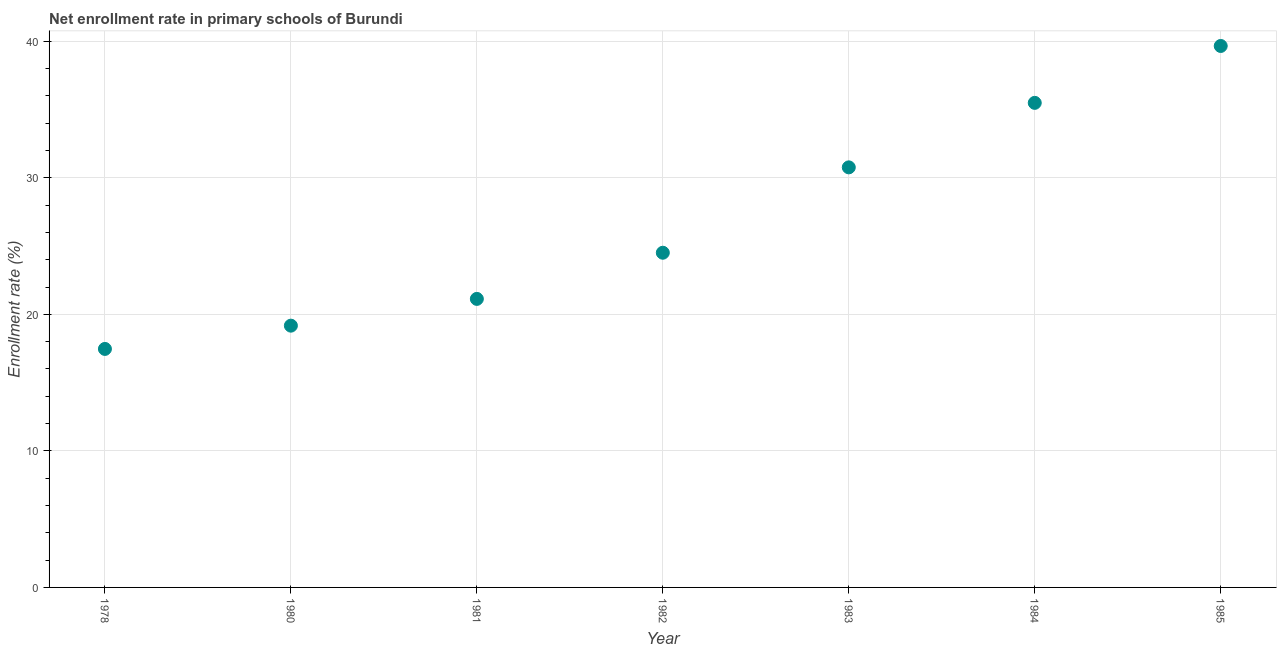What is the net enrollment rate in primary schools in 1978?
Your answer should be very brief. 17.47. Across all years, what is the maximum net enrollment rate in primary schools?
Offer a terse response. 39.65. Across all years, what is the minimum net enrollment rate in primary schools?
Offer a very short reply. 17.47. In which year was the net enrollment rate in primary schools maximum?
Offer a terse response. 1985. In which year was the net enrollment rate in primary schools minimum?
Offer a terse response. 1978. What is the sum of the net enrollment rate in primary schools?
Provide a short and direct response. 188.18. What is the difference between the net enrollment rate in primary schools in 1982 and 1983?
Your answer should be very brief. -6.25. What is the average net enrollment rate in primary schools per year?
Give a very brief answer. 26.88. What is the median net enrollment rate in primary schools?
Make the answer very short. 24.51. What is the ratio of the net enrollment rate in primary schools in 1983 to that in 1984?
Offer a very short reply. 0.87. Is the difference between the net enrollment rate in primary schools in 1980 and 1981 greater than the difference between any two years?
Your answer should be compact. No. What is the difference between the highest and the second highest net enrollment rate in primary schools?
Keep it short and to the point. 4.17. Is the sum of the net enrollment rate in primary schools in 1980 and 1981 greater than the maximum net enrollment rate in primary schools across all years?
Give a very brief answer. Yes. What is the difference between the highest and the lowest net enrollment rate in primary schools?
Your answer should be very brief. 22.19. Does the net enrollment rate in primary schools monotonically increase over the years?
Provide a succinct answer. Yes. How many dotlines are there?
Keep it short and to the point. 1. How many years are there in the graph?
Provide a succinct answer. 7. What is the difference between two consecutive major ticks on the Y-axis?
Your answer should be compact. 10. Are the values on the major ticks of Y-axis written in scientific E-notation?
Offer a terse response. No. Does the graph contain any zero values?
Your answer should be very brief. No. Does the graph contain grids?
Make the answer very short. Yes. What is the title of the graph?
Give a very brief answer. Net enrollment rate in primary schools of Burundi. What is the label or title of the X-axis?
Give a very brief answer. Year. What is the label or title of the Y-axis?
Ensure brevity in your answer.  Enrollment rate (%). What is the Enrollment rate (%) in 1978?
Offer a terse response. 17.47. What is the Enrollment rate (%) in 1980?
Your answer should be compact. 19.17. What is the Enrollment rate (%) in 1981?
Provide a short and direct response. 21.13. What is the Enrollment rate (%) in 1982?
Ensure brevity in your answer.  24.51. What is the Enrollment rate (%) in 1983?
Keep it short and to the point. 30.76. What is the Enrollment rate (%) in 1984?
Offer a terse response. 35.49. What is the Enrollment rate (%) in 1985?
Provide a short and direct response. 39.65. What is the difference between the Enrollment rate (%) in 1978 and 1980?
Your answer should be compact. -1.7. What is the difference between the Enrollment rate (%) in 1978 and 1981?
Your answer should be very brief. -3.66. What is the difference between the Enrollment rate (%) in 1978 and 1982?
Offer a very short reply. -7.04. What is the difference between the Enrollment rate (%) in 1978 and 1983?
Your response must be concise. -13.3. What is the difference between the Enrollment rate (%) in 1978 and 1984?
Provide a succinct answer. -18.02. What is the difference between the Enrollment rate (%) in 1978 and 1985?
Offer a very short reply. -22.19. What is the difference between the Enrollment rate (%) in 1980 and 1981?
Your answer should be very brief. -1.96. What is the difference between the Enrollment rate (%) in 1980 and 1982?
Offer a very short reply. -5.34. What is the difference between the Enrollment rate (%) in 1980 and 1983?
Your answer should be very brief. -11.59. What is the difference between the Enrollment rate (%) in 1980 and 1984?
Provide a succinct answer. -16.32. What is the difference between the Enrollment rate (%) in 1980 and 1985?
Give a very brief answer. -20.48. What is the difference between the Enrollment rate (%) in 1981 and 1982?
Give a very brief answer. -3.38. What is the difference between the Enrollment rate (%) in 1981 and 1983?
Your answer should be very brief. -9.63. What is the difference between the Enrollment rate (%) in 1981 and 1984?
Give a very brief answer. -14.36. What is the difference between the Enrollment rate (%) in 1981 and 1985?
Offer a very short reply. -18.52. What is the difference between the Enrollment rate (%) in 1982 and 1983?
Your answer should be very brief. -6.25. What is the difference between the Enrollment rate (%) in 1982 and 1984?
Ensure brevity in your answer.  -10.98. What is the difference between the Enrollment rate (%) in 1982 and 1985?
Your answer should be very brief. -15.14. What is the difference between the Enrollment rate (%) in 1983 and 1984?
Offer a very short reply. -4.72. What is the difference between the Enrollment rate (%) in 1983 and 1985?
Your response must be concise. -8.89. What is the difference between the Enrollment rate (%) in 1984 and 1985?
Give a very brief answer. -4.17. What is the ratio of the Enrollment rate (%) in 1978 to that in 1980?
Give a very brief answer. 0.91. What is the ratio of the Enrollment rate (%) in 1978 to that in 1981?
Give a very brief answer. 0.83. What is the ratio of the Enrollment rate (%) in 1978 to that in 1982?
Your response must be concise. 0.71. What is the ratio of the Enrollment rate (%) in 1978 to that in 1983?
Your answer should be compact. 0.57. What is the ratio of the Enrollment rate (%) in 1978 to that in 1984?
Give a very brief answer. 0.49. What is the ratio of the Enrollment rate (%) in 1978 to that in 1985?
Give a very brief answer. 0.44. What is the ratio of the Enrollment rate (%) in 1980 to that in 1981?
Your response must be concise. 0.91. What is the ratio of the Enrollment rate (%) in 1980 to that in 1982?
Your answer should be very brief. 0.78. What is the ratio of the Enrollment rate (%) in 1980 to that in 1983?
Ensure brevity in your answer.  0.62. What is the ratio of the Enrollment rate (%) in 1980 to that in 1984?
Your answer should be very brief. 0.54. What is the ratio of the Enrollment rate (%) in 1980 to that in 1985?
Keep it short and to the point. 0.48. What is the ratio of the Enrollment rate (%) in 1981 to that in 1982?
Provide a short and direct response. 0.86. What is the ratio of the Enrollment rate (%) in 1981 to that in 1983?
Your answer should be compact. 0.69. What is the ratio of the Enrollment rate (%) in 1981 to that in 1984?
Your answer should be compact. 0.59. What is the ratio of the Enrollment rate (%) in 1981 to that in 1985?
Offer a very short reply. 0.53. What is the ratio of the Enrollment rate (%) in 1982 to that in 1983?
Make the answer very short. 0.8. What is the ratio of the Enrollment rate (%) in 1982 to that in 1984?
Provide a succinct answer. 0.69. What is the ratio of the Enrollment rate (%) in 1982 to that in 1985?
Offer a terse response. 0.62. What is the ratio of the Enrollment rate (%) in 1983 to that in 1984?
Offer a terse response. 0.87. What is the ratio of the Enrollment rate (%) in 1983 to that in 1985?
Make the answer very short. 0.78. What is the ratio of the Enrollment rate (%) in 1984 to that in 1985?
Ensure brevity in your answer.  0.9. 